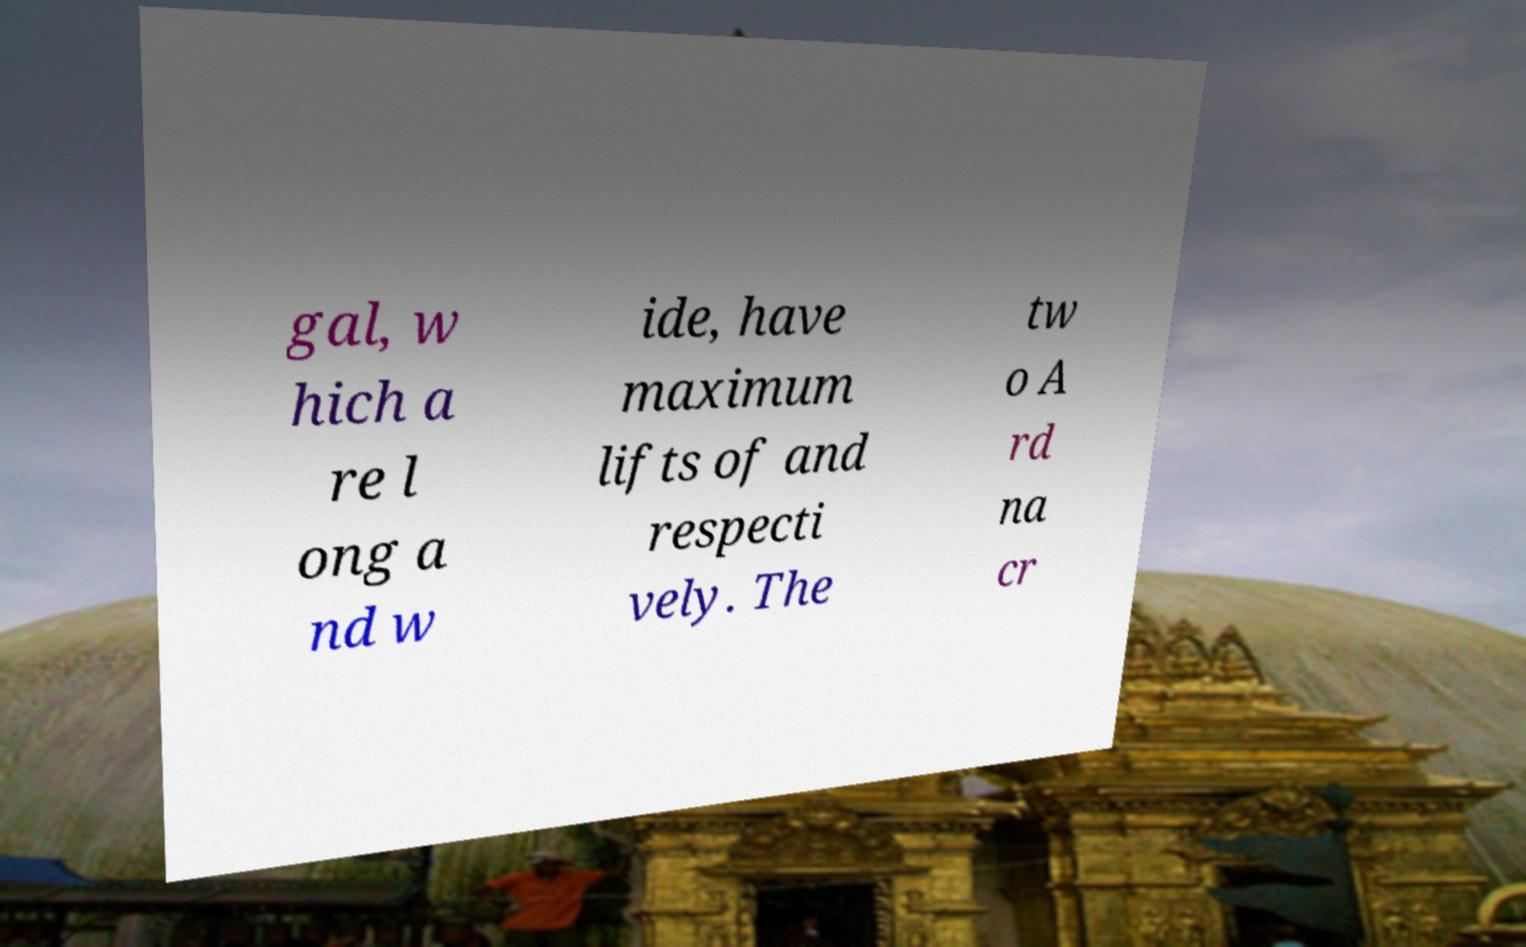Can you read and provide the text displayed in the image?This photo seems to have some interesting text. Can you extract and type it out for me? gal, w hich a re l ong a nd w ide, have maximum lifts of and respecti vely. The tw o A rd na cr 